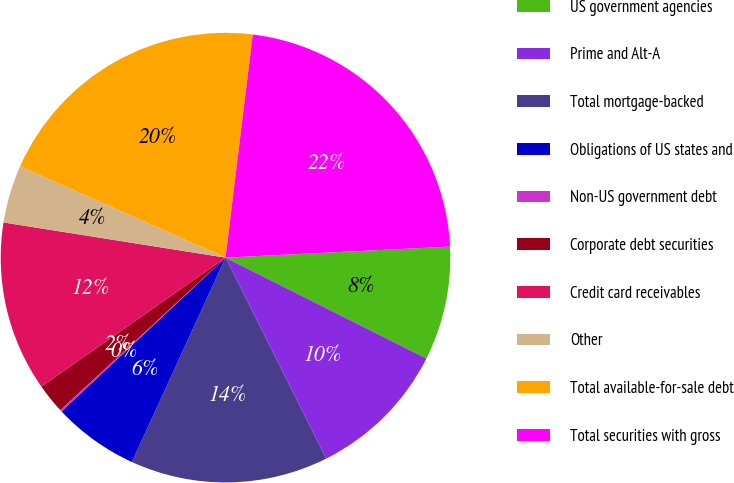Convert chart. <chart><loc_0><loc_0><loc_500><loc_500><pie_chart><fcel>US government agencies<fcel>Prime and Alt-A<fcel>Total mortgage-backed<fcel>Obligations of US states and<fcel>Non-US government debt<fcel>Corporate debt securities<fcel>Credit card receivables<fcel>Other<fcel>Total available-for-sale debt<fcel>Total securities with gross<nl><fcel>8.19%<fcel>10.2%<fcel>14.23%<fcel>6.17%<fcel>0.13%<fcel>2.14%<fcel>12.22%<fcel>4.16%<fcel>20.27%<fcel>22.28%<nl></chart> 